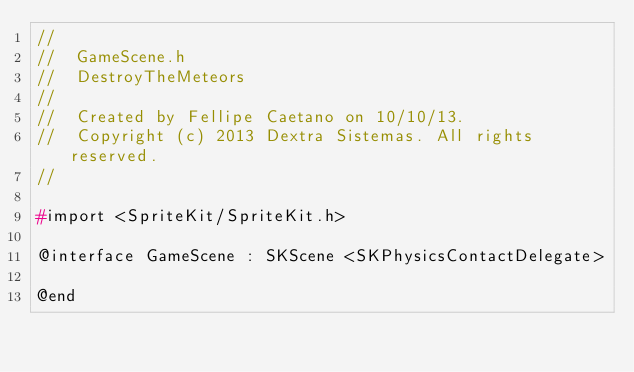<code> <loc_0><loc_0><loc_500><loc_500><_C_>//
//  GameScene.h
//  DestroyTheMeteors
//
//  Created by Fellipe Caetano on 10/10/13.
//  Copyright (c) 2013 Dextra Sistemas. All rights reserved.
//

#import <SpriteKit/SpriteKit.h>

@interface GameScene : SKScene <SKPhysicsContactDelegate>

@end
</code> 